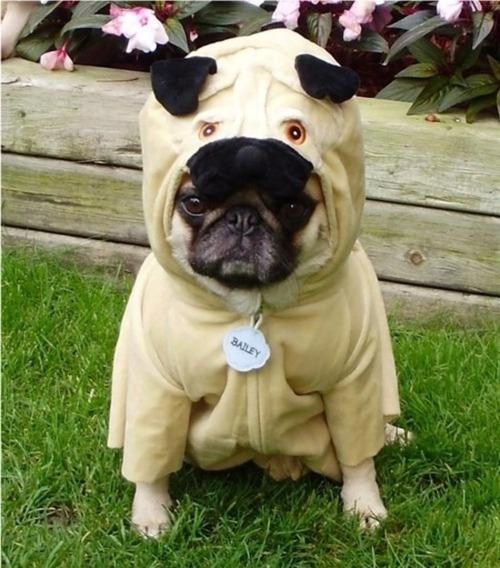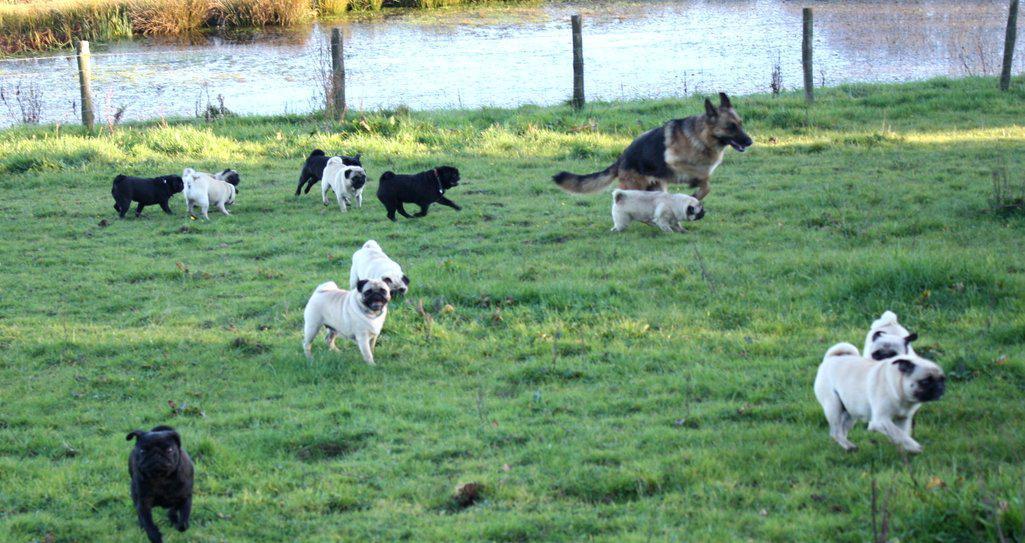The first image is the image on the left, the second image is the image on the right. Given the left and right images, does the statement "People are seen with the dogs on the left." hold true? Answer yes or no. No. 